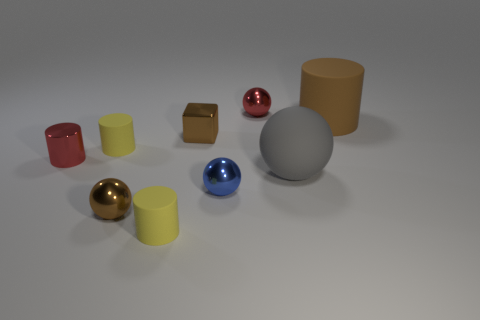Are there an equal number of big brown matte cylinders that are left of the brown metal cube and brown shiny objects that are behind the tiny red metallic cylinder?
Offer a terse response. No. How many small metallic things have the same color as the metallic cylinder?
Give a very brief answer. 1. What material is the large object that is the same color as the tiny metal block?
Give a very brief answer. Rubber. What number of matte things are either large things or big blue things?
Your answer should be compact. 2. Does the small yellow object behind the small blue ball have the same shape as the red metal object that is in front of the big brown matte object?
Keep it short and to the point. Yes. How many balls are in front of the large brown cylinder?
Offer a terse response. 3. Is there a small object made of the same material as the tiny brown block?
Your response must be concise. Yes. What is the material of the brown thing that is the same size as the gray object?
Keep it short and to the point. Rubber. Do the large ball and the large cylinder have the same material?
Your answer should be very brief. Yes. How many things are either large gray objects or yellow metallic cubes?
Your response must be concise. 1. 